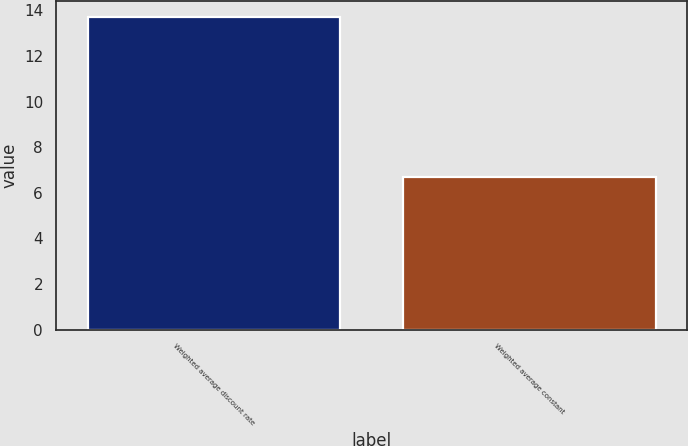<chart> <loc_0><loc_0><loc_500><loc_500><bar_chart><fcel>Weighted average discount rate<fcel>Weighted average constant<nl><fcel>13.7<fcel>6.7<nl></chart> 